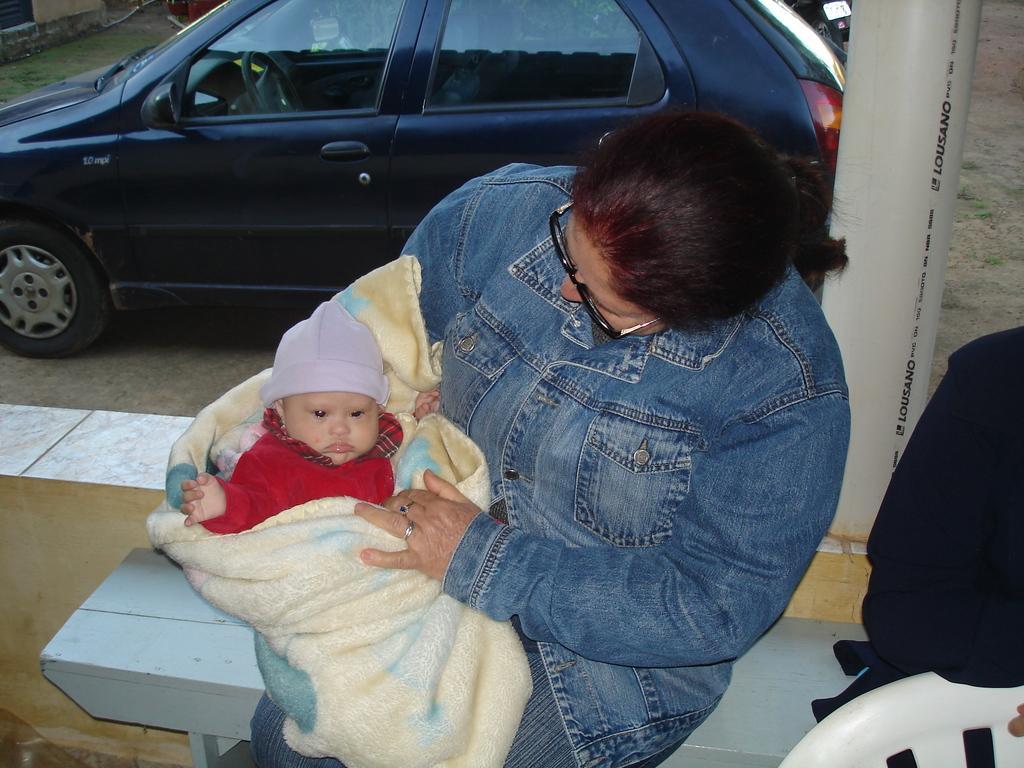How would you summarize this image in a sentence or two? In the center of the image we can see a lady holding a baby and there is a chair. In the background there is a car and we can see a pillar. At the bottom there is a bench. On the right there is a person. 